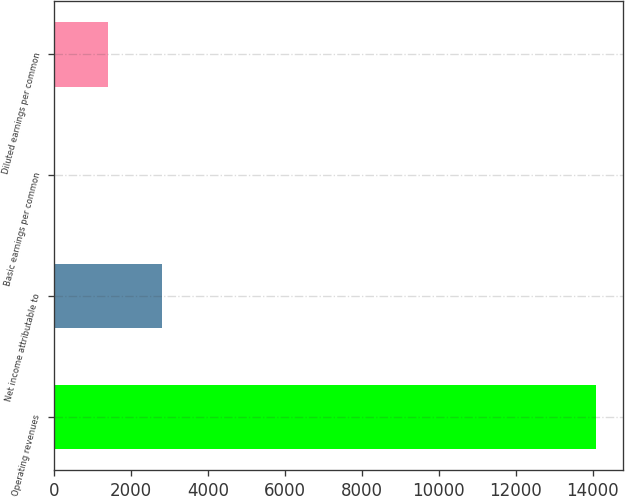Convert chart to OTSL. <chart><loc_0><loc_0><loc_500><loc_500><bar_chart><fcel>Operating revenues<fcel>Net income attributable to<fcel>Basic earnings per common<fcel>Diluted earnings per common<nl><fcel>14085<fcel>2817.2<fcel>0.24<fcel>1408.72<nl></chart> 